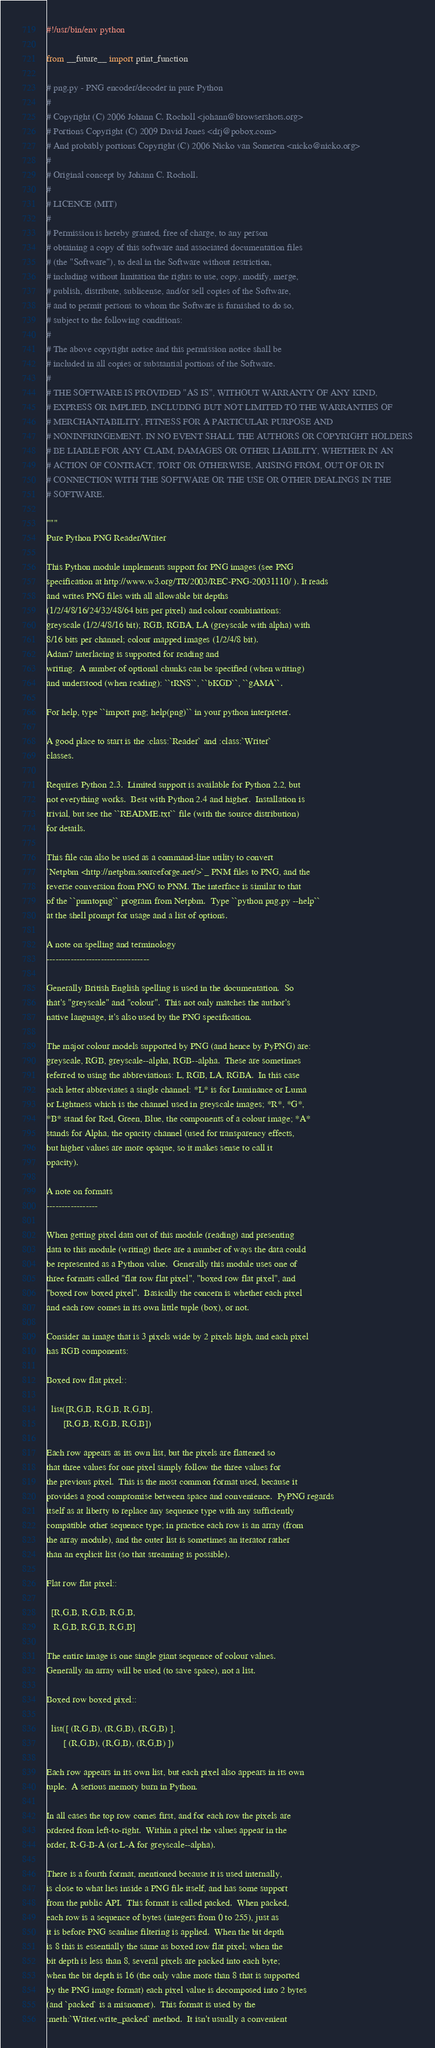Convert code to text. <code><loc_0><loc_0><loc_500><loc_500><_Python_>#!/usr/bin/env python

from __future__ import print_function

# png.py - PNG encoder/decoder in pure Python
#
# Copyright (C) 2006 Johann C. Rocholl <johann@browsershots.org>
# Portions Copyright (C) 2009 David Jones <drj@pobox.com>
# And probably portions Copyright (C) 2006 Nicko van Someren <nicko@nicko.org>
#
# Original concept by Johann C. Rocholl.
#
# LICENCE (MIT)
#
# Permission is hereby granted, free of charge, to any person
# obtaining a copy of this software and associated documentation files
# (the "Software"), to deal in the Software without restriction,
# including without limitation the rights to use, copy, modify, merge,
# publish, distribute, sublicense, and/or sell copies of the Software,
# and to permit persons to whom the Software is furnished to do so,
# subject to the following conditions:
#
# The above copyright notice and this permission notice shall be
# included in all copies or substantial portions of the Software.
#
# THE SOFTWARE IS PROVIDED "AS IS", WITHOUT WARRANTY OF ANY KIND,
# EXPRESS OR IMPLIED, INCLUDING BUT NOT LIMITED TO THE WARRANTIES OF
# MERCHANTABILITY, FITNESS FOR A PARTICULAR PURPOSE AND
# NONINFRINGEMENT. IN NO EVENT SHALL THE AUTHORS OR COPYRIGHT HOLDERS
# BE LIABLE FOR ANY CLAIM, DAMAGES OR OTHER LIABILITY, WHETHER IN AN
# ACTION OF CONTRACT, TORT OR OTHERWISE, ARISING FROM, OUT OF OR IN
# CONNECTION WITH THE SOFTWARE OR THE USE OR OTHER DEALINGS IN THE
# SOFTWARE.

"""
Pure Python PNG Reader/Writer

This Python module implements support for PNG images (see PNG
specification at http://www.w3.org/TR/2003/REC-PNG-20031110/ ). It reads
and writes PNG files with all allowable bit depths
(1/2/4/8/16/24/32/48/64 bits per pixel) and colour combinations:
greyscale (1/2/4/8/16 bit); RGB, RGBA, LA (greyscale with alpha) with
8/16 bits per channel; colour mapped images (1/2/4/8 bit).
Adam7 interlacing is supported for reading and
writing.  A number of optional chunks can be specified (when writing)
and understood (when reading): ``tRNS``, ``bKGD``, ``gAMA``.

For help, type ``import png; help(png)`` in your python interpreter.

A good place to start is the :class:`Reader` and :class:`Writer`
classes.

Requires Python 2.3.  Limited support is available for Python 2.2, but
not everything works.  Best with Python 2.4 and higher.  Installation is
trivial, but see the ``README.txt`` file (with the source distribution)
for details.

This file can also be used as a command-line utility to convert
`Netpbm <http://netpbm.sourceforge.net/>`_ PNM files to PNG, and the
reverse conversion from PNG to PNM. The interface is similar to that
of the ``pnmtopng`` program from Netpbm.  Type ``python png.py --help``
at the shell prompt for usage and a list of options.

A note on spelling and terminology
----------------------------------

Generally British English spelling is used in the documentation.  So
that's "greyscale" and "colour".  This not only matches the author's
native language, it's also used by the PNG specification.

The major colour models supported by PNG (and hence by PyPNG) are:
greyscale, RGB, greyscale--alpha, RGB--alpha.  These are sometimes
referred to using the abbreviations: L, RGB, LA, RGBA.  In this case
each letter abbreviates a single channel: *L* is for Luminance or Luma
or Lightness which is the channel used in greyscale images; *R*, *G*,
*B* stand for Red, Green, Blue, the components of a colour image; *A*
stands for Alpha, the opacity channel (used for transparency effects,
but higher values are more opaque, so it makes sense to call it 
opacity).

A note on formats
-----------------

When getting pixel data out of this module (reading) and presenting
data to this module (writing) there are a number of ways the data could
be represented as a Python value.  Generally this module uses one of
three formats called "flat row flat pixel", "boxed row flat pixel", and
"boxed row boxed pixel".  Basically the concern is whether each pixel
and each row comes in its own little tuple (box), or not.

Consider an image that is 3 pixels wide by 2 pixels high, and each pixel
has RGB components:

Boxed row flat pixel::

  list([R,G,B, R,G,B, R,G,B],
       [R,G,B, R,G,B, R,G,B])

Each row appears as its own list, but the pixels are flattened so
that three values for one pixel simply follow the three values for
the previous pixel.  This is the most common format used, because it
provides a good compromise between space and convenience.  PyPNG regards
itself as at liberty to replace any sequence type with any sufficiently
compatible other sequence type; in practice each row is an array (from
the array module), and the outer list is sometimes an iterator rather
than an explicit list (so that streaming is possible).

Flat row flat pixel::

  [R,G,B, R,G,B, R,G,B,
   R,G,B, R,G,B, R,G,B]

The entire image is one single giant sequence of colour values.
Generally an array will be used (to save space), not a list.

Boxed row boxed pixel::

  list([ (R,G,B), (R,G,B), (R,G,B) ],
       [ (R,G,B), (R,G,B), (R,G,B) ])

Each row appears in its own list, but each pixel also appears in its own
tuple.  A serious memory burn in Python.

In all cases the top row comes first, and for each row the pixels are
ordered from left-to-right.  Within a pixel the values appear in the
order, R-G-B-A (or L-A for greyscale--alpha).

There is a fourth format, mentioned because it is used internally,
is close to what lies inside a PNG file itself, and has some support
from the public API.  This format is called packed.  When packed,
each row is a sequence of bytes (integers from 0 to 255), just as
it is before PNG scanline filtering is applied.  When the bit depth
is 8 this is essentially the same as boxed row flat pixel; when the
bit depth is less than 8, several pixels are packed into each byte;
when the bit depth is 16 (the only value more than 8 that is supported
by the PNG image format) each pixel value is decomposed into 2 bytes
(and `packed` is a misnomer).  This format is used by the
:meth:`Writer.write_packed` method.  It isn't usually a convenient</code> 